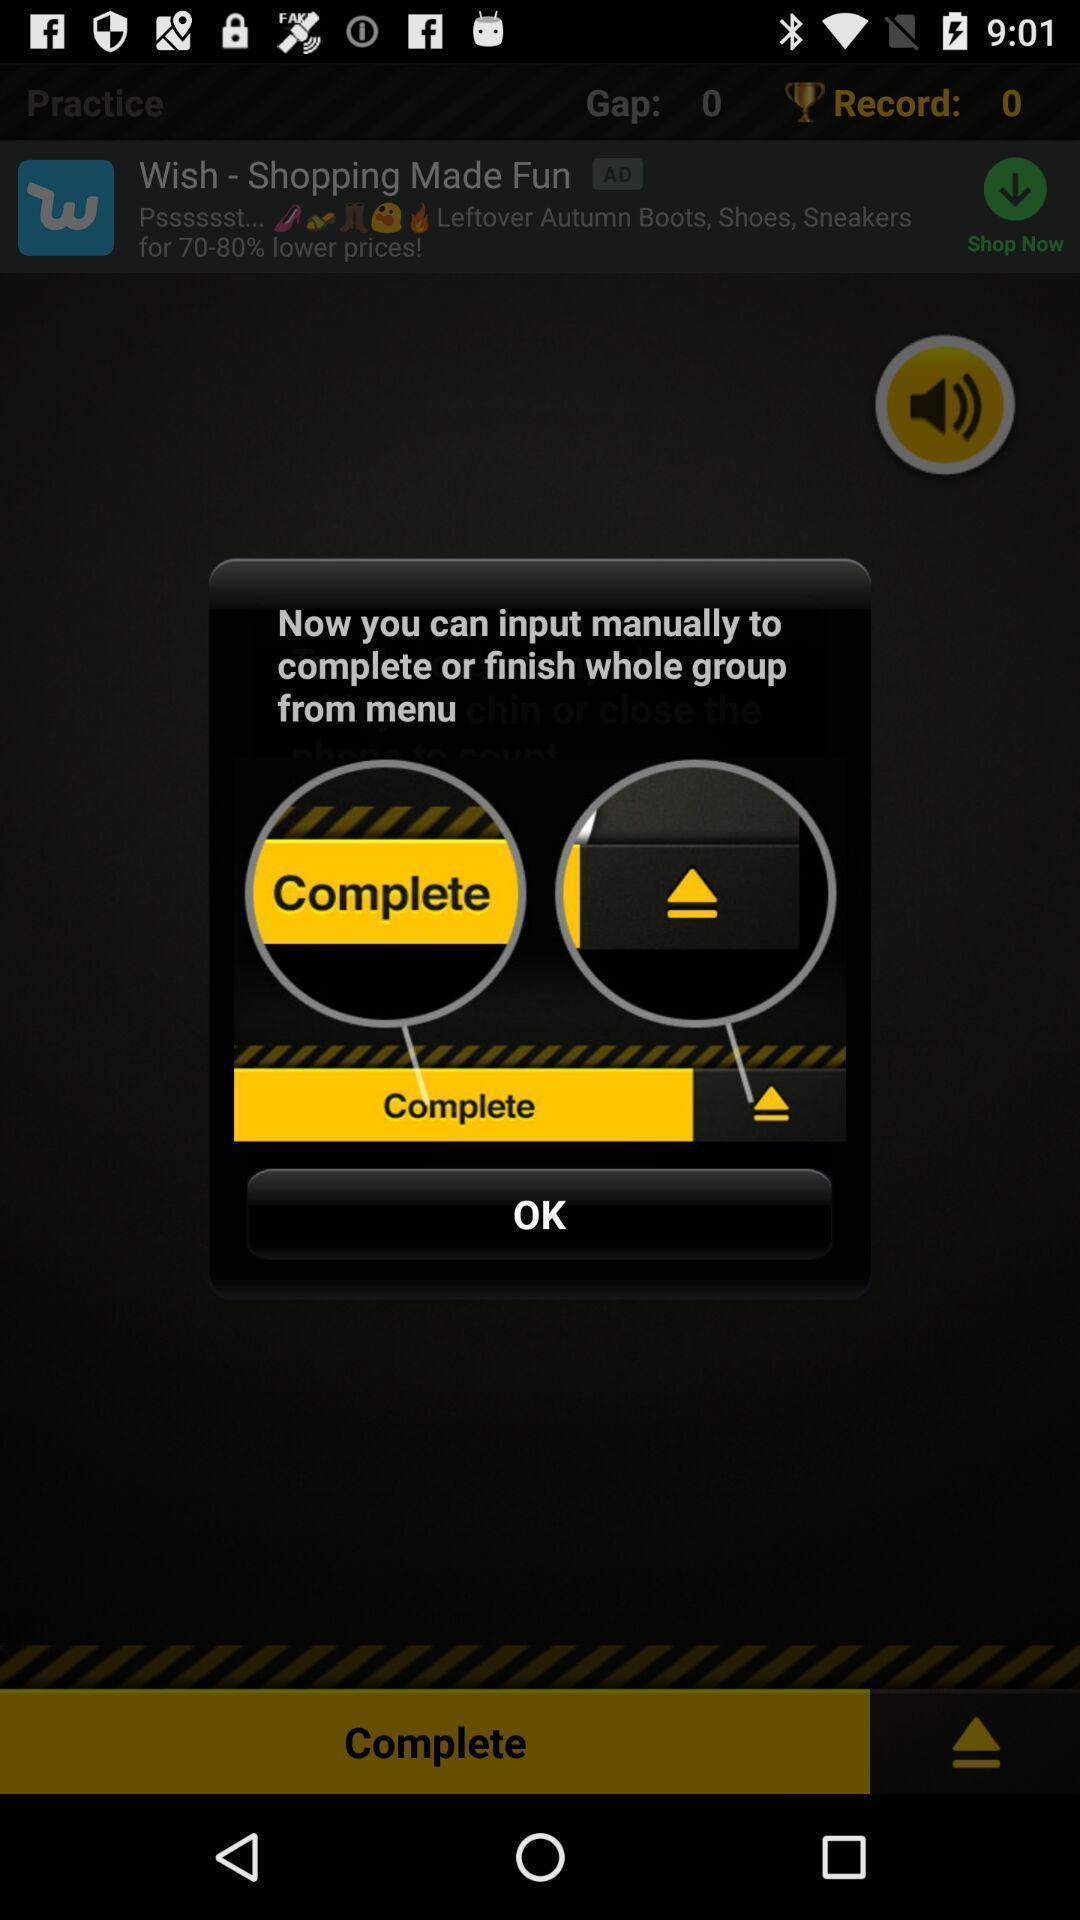Provide a description of this screenshot. Screen displaying demo instructions to access an application. 